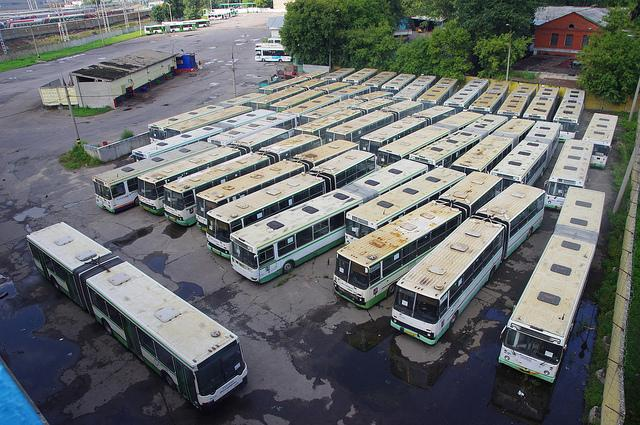What phrase best describes this place? Please explain your reasoning. bus depot. This would be a place they can park a bunch of busses. 